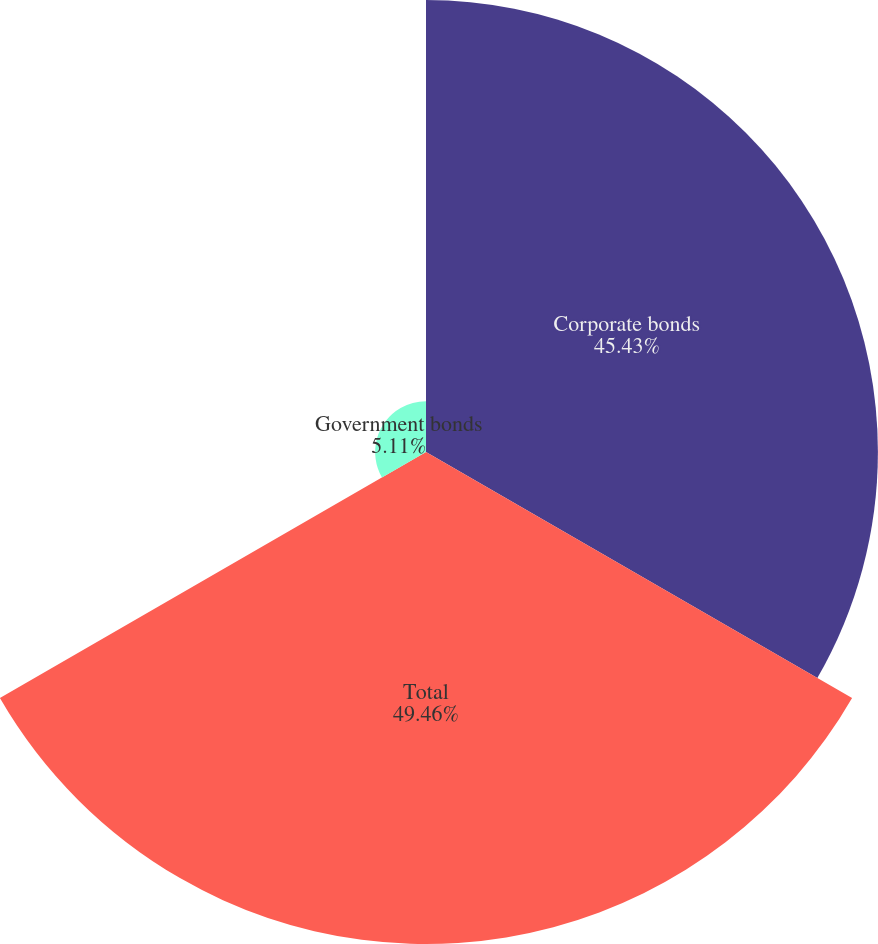Convert chart to OTSL. <chart><loc_0><loc_0><loc_500><loc_500><pie_chart><fcel>Corporate bonds<fcel>Total<fcel>Government bonds<nl><fcel>45.43%<fcel>49.46%<fcel>5.11%<nl></chart> 